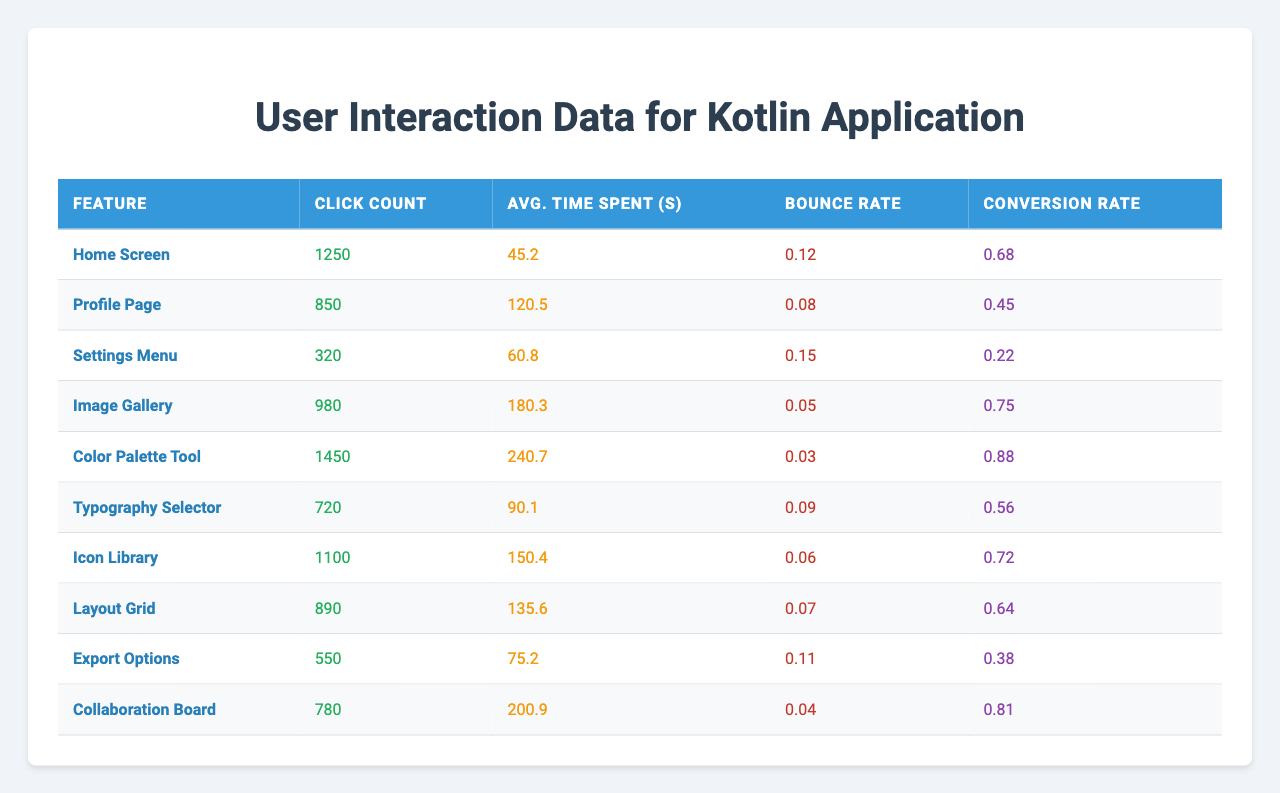What is the feature with the highest click count? The table shows the click counts for each feature. By comparing these values, we see that the "Color Palette Tool" has the highest click count of 1450.
Answer: Color Palette Tool Which feature has the lowest bounce rate? By examining the bounce rates in the table, the "Color Palette Tool" displays the lowest bounce rate of 0.03.
Answer: Color Palette Tool What is the average time spent on the "Image Gallery"? The average time spent on the "Image Gallery" is listed in the table as 180.3 seconds.
Answer: 180.3 seconds Calculate the total click count for all features. To find the total click count, sum all the values in the Click Count column: 1250 + 850 + 320 + 980 + 1450 + 720 + 1100 + 890 + 550 + 780 = 7020.
Answer: 7020 Is the conversion rate for the "Profile Page" higher than 0.5? The conversion rate for the "Profile Page" is 0.45, which is less than 0.5.
Answer: No What is the difference in average time spent between the "Settings Menu" and "Image Gallery"? The average time spent on "Settings Menu" is 60.8 seconds and on "Image Gallery" is 180.3 seconds. The difference is 180.3 - 60.8 = 119.5 seconds.
Answer: 119.5 seconds Which feature has a higher conversion rate: "Collaboration Board" or "Image Gallery"? The conversion rate for the "Collaboration Board" is 0.81 while for the "Image Gallery," it is 0.75. Therefore, the "Collaboration Board" has a higher conversion rate.
Answer: Collaboration Board What is the average bounce rate for all features? To calculate the average bounce rate, sum all the bounce rates (0.12 + 0.08 + 0.15 + 0.05 + 0.03 + 0.09 + 0.06 + 0.07 + 0.11 + 0.04 = 0.70) and divide by the number of features (10): 0.70 / 10 = 0.07.
Answer: 0.07 Which feature had more than 1000 clicks and the highest average time spent? The "Color Palette Tool" had 1450 clicks and the highest average time spent of 240.7 seconds, making it the only feature matching both criteria.
Answer: Color Palette Tool What is the overall trend regarding click counts and bounce rates for features? Upon observation, most features with higher click counts, like the "Color Palette Tool," tend to have lower bounce rates, indicating effective user engagement.
Answer: Higher clicks, lower bounce rates 